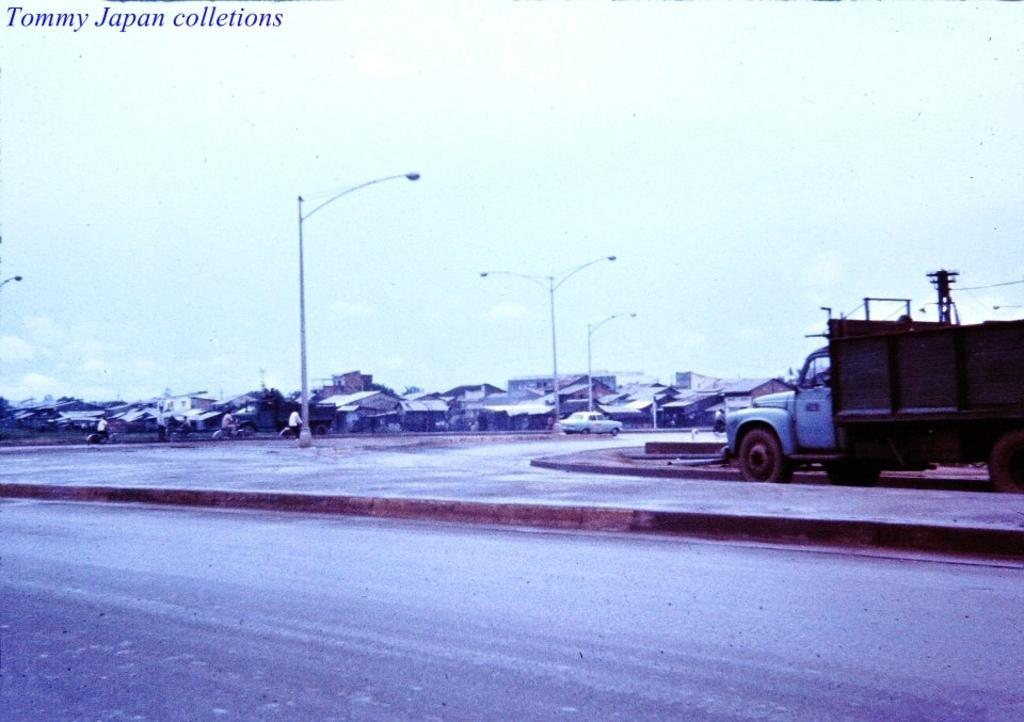In one or two sentences, can you explain what this image depicts? In this picture we can observe a road. There is a vehicle moving on this road. On the right side we can observe another vehicle. There are some poles. We can observe some houses. In the background there is a sky. 